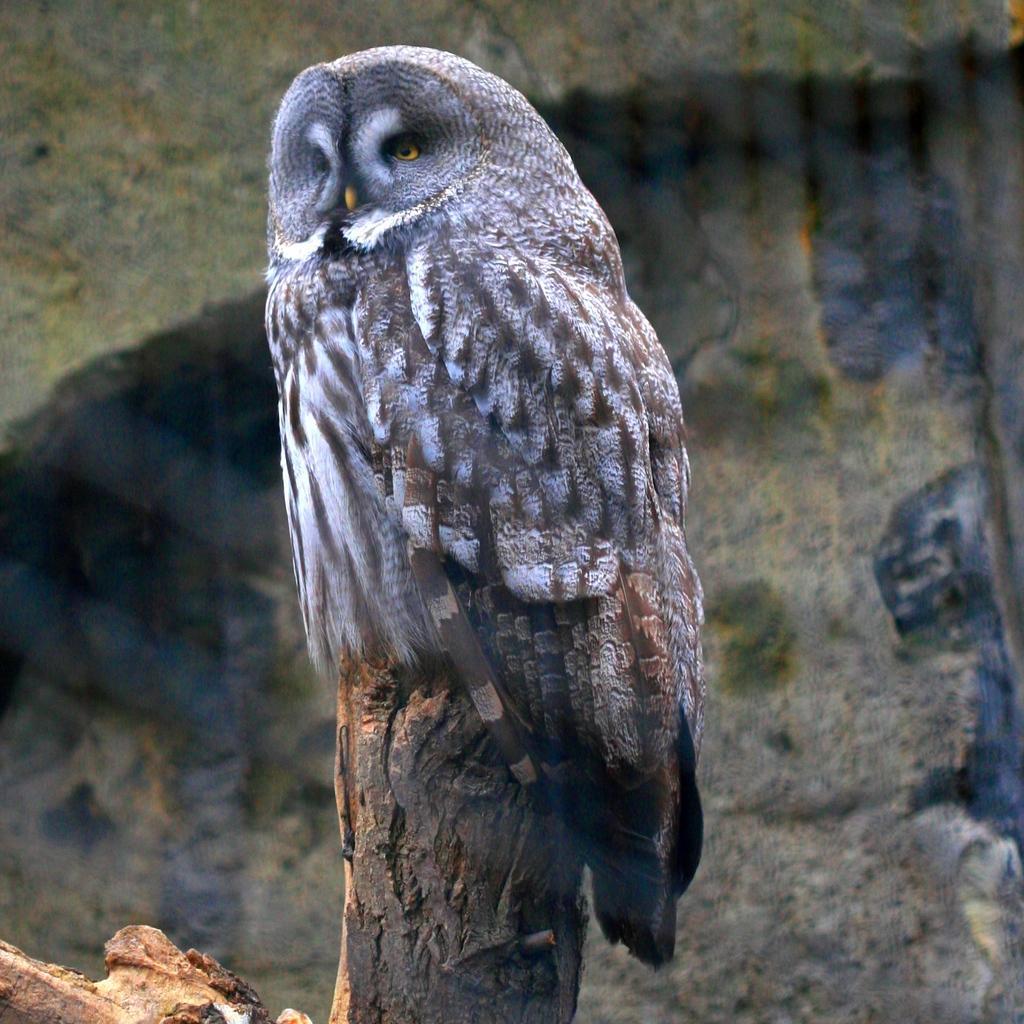Describe this image in one or two sentences. In this image in the center there is an owl on the wooden stick, in the background there is a wall. 